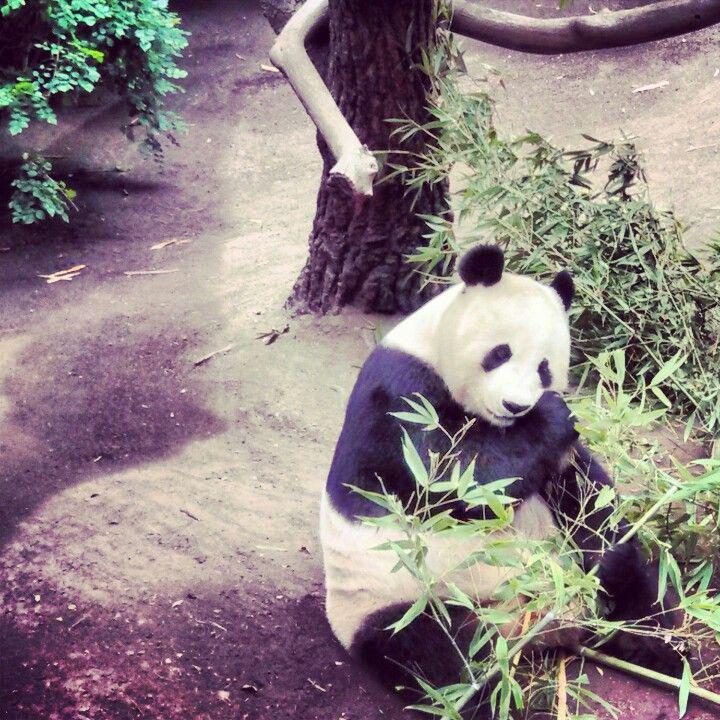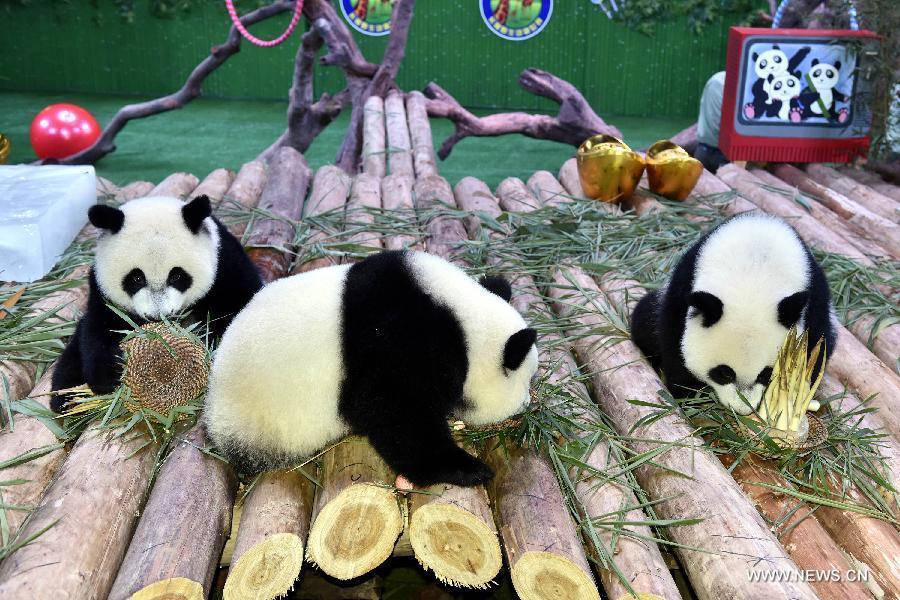The first image is the image on the left, the second image is the image on the right. Evaluate the accuracy of this statement regarding the images: "People are interacting with a panda in the image on the left.". Is it true? Answer yes or no. No. The first image is the image on the left, the second image is the image on the right. For the images shown, is this caption "An image shows at least one person in protective gear behind a panda, grasping it" true? Answer yes or no. No. 